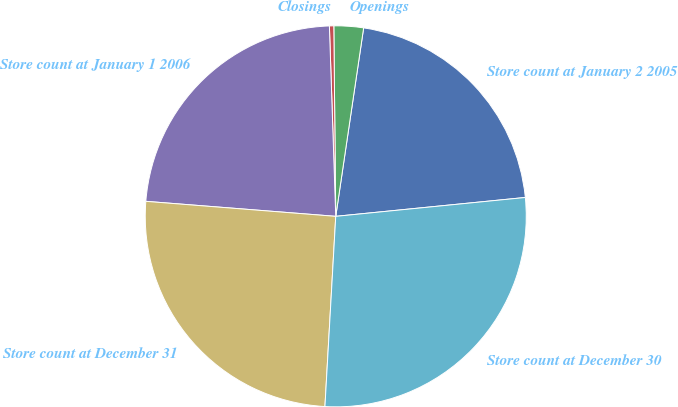Convert chart. <chart><loc_0><loc_0><loc_500><loc_500><pie_chart><fcel>Store count at January 2 2005<fcel>Openings<fcel>Closings<fcel>Store count at January 1 2006<fcel>Store count at December 31<fcel>Store count at December 30<nl><fcel>21.08%<fcel>2.5%<fcel>0.37%<fcel>23.21%<fcel>25.35%<fcel>27.48%<nl></chart> 